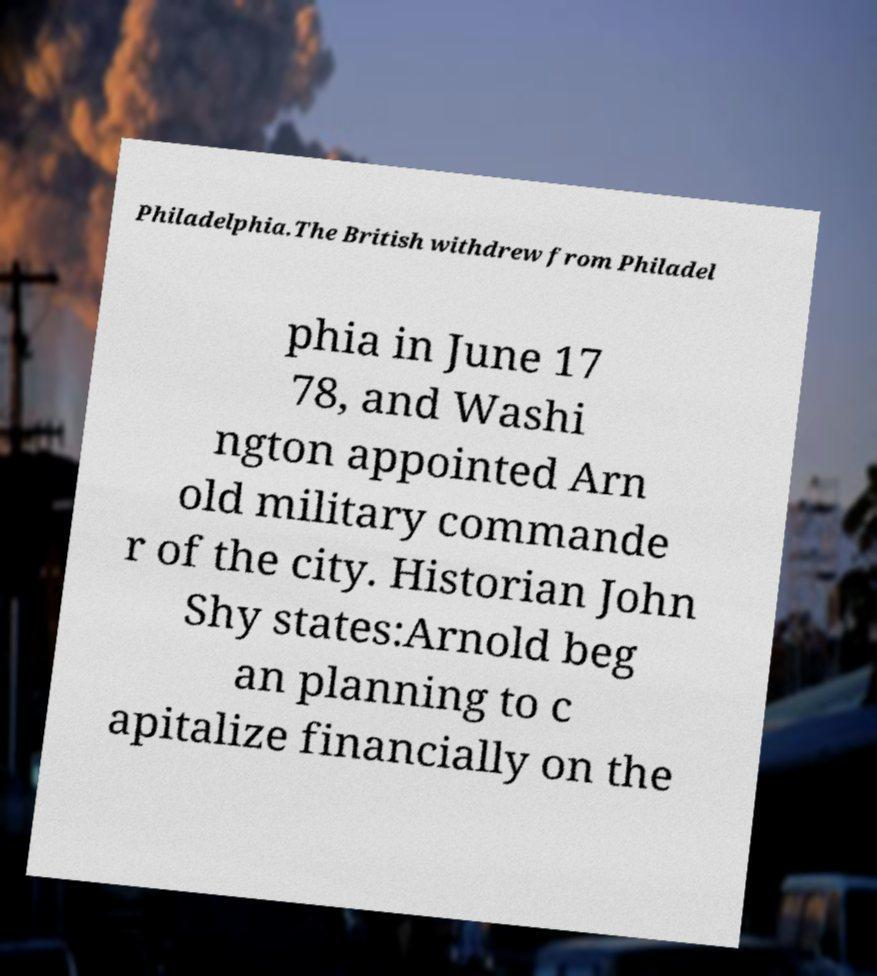Could you extract and type out the text from this image? Philadelphia.The British withdrew from Philadel phia in June 17 78, and Washi ngton appointed Arn old military commande r of the city. Historian John Shy states:Arnold beg an planning to c apitalize financially on the 